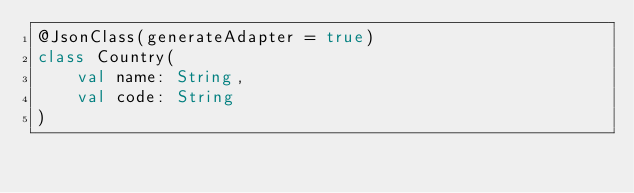Convert code to text. <code><loc_0><loc_0><loc_500><loc_500><_Kotlin_>@JsonClass(generateAdapter = true)
class Country(
    val name: String,
    val code: String
)</code> 